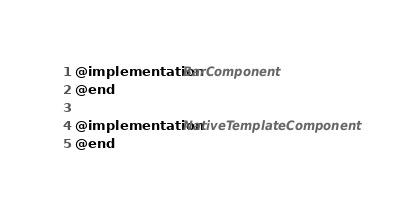Convert code to text. <code><loc_0><loc_0><loc_500><loc_500><_ObjectiveC_>
@implementation BarComponent
@end

@implementation NativeTemplateComponent
@end
</code> 